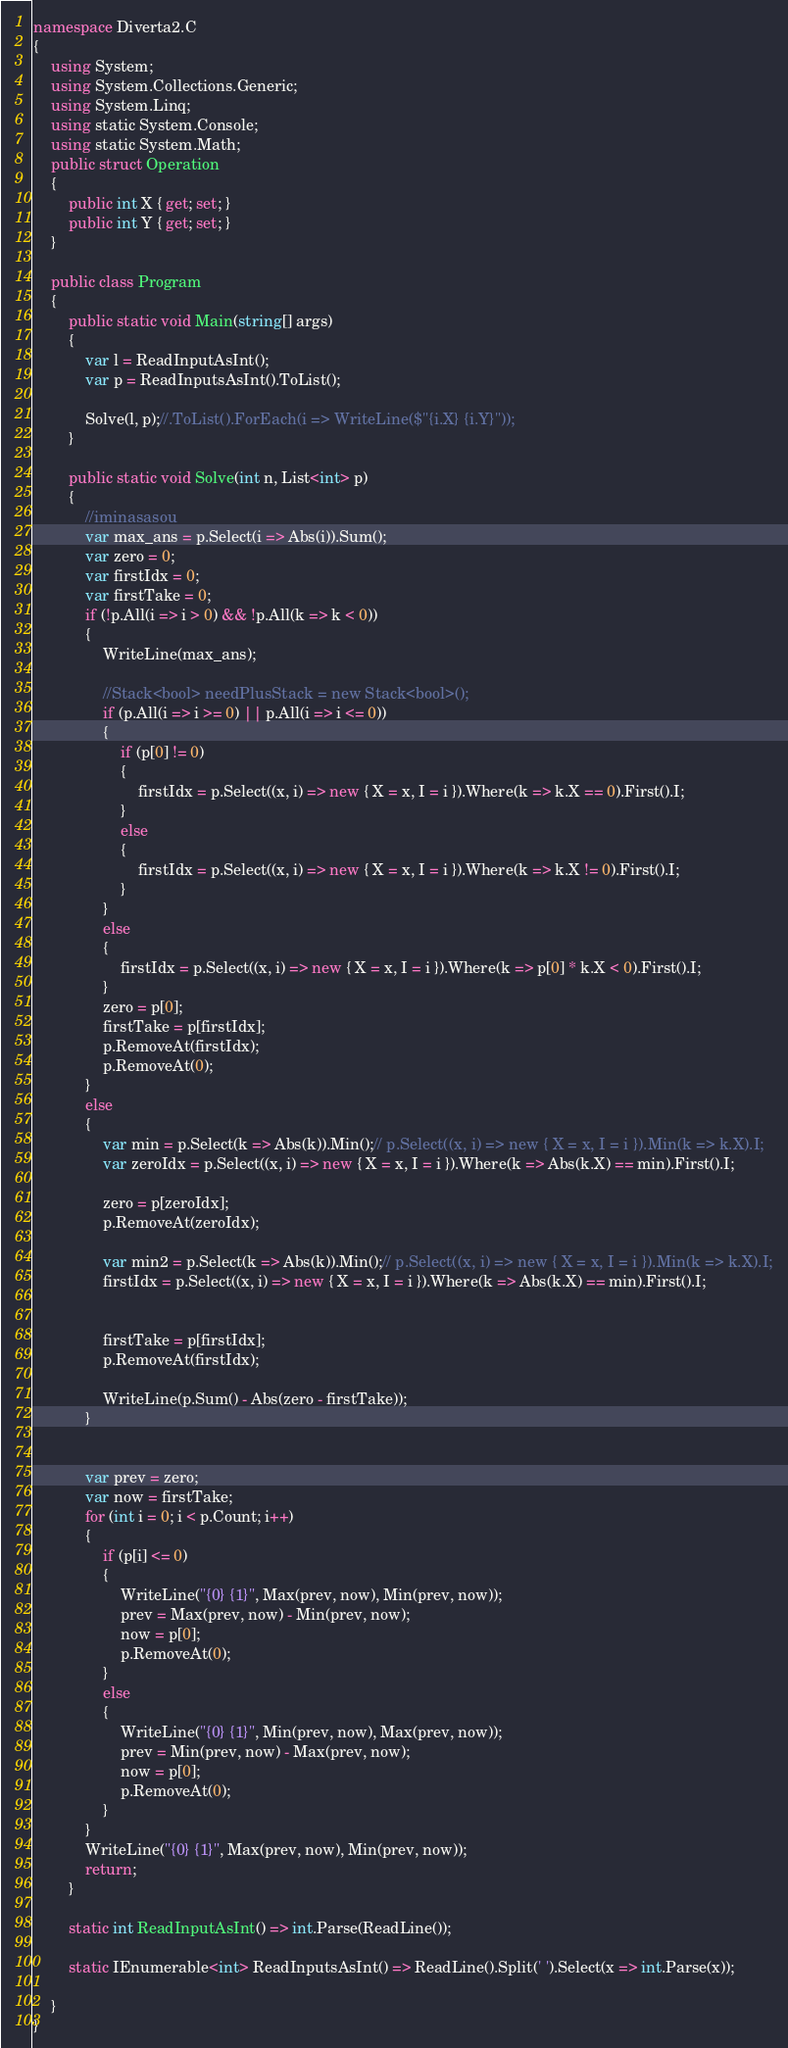<code> <loc_0><loc_0><loc_500><loc_500><_C#_>namespace Diverta2.C
{
    using System;
    using System.Collections.Generic;
    using System.Linq;
    using static System.Console;
    using static System.Math;
    public struct Operation
    {
        public int X { get; set; }
        public int Y { get; set; }
    }

    public class Program
    {
        public static void Main(string[] args)
        {
            var l = ReadInputAsInt();
            var p = ReadInputsAsInt().ToList();

            Solve(l, p);//.ToList().ForEach(i => WriteLine($"{i.X} {i.Y}"));
        }

        public static void Solve(int n, List<int> p)
        {
            //iminasasou
            var max_ans = p.Select(i => Abs(i)).Sum();
            var zero = 0;
            var firstIdx = 0;
            var firstTake = 0;
            if (!p.All(i => i > 0) && !p.All(k => k < 0))
            {
                WriteLine(max_ans);

                //Stack<bool> needPlusStack = new Stack<bool>();
                if (p.All(i => i >= 0) || p.All(i => i <= 0))
                {
                    if (p[0] != 0)
                    {
                        firstIdx = p.Select((x, i) => new { X = x, I = i }).Where(k => k.X == 0).First().I;
                    }
                    else
                    {
                        firstIdx = p.Select((x, i) => new { X = x, I = i }).Where(k => k.X != 0).First().I;
                    }
                }
                else
                {
                    firstIdx = p.Select((x, i) => new { X = x, I = i }).Where(k => p[0] * k.X < 0).First().I;
                }
                zero = p[0];
                firstTake = p[firstIdx];
                p.RemoveAt(firstIdx);
                p.RemoveAt(0);
            }
            else
            {
                var min = p.Select(k => Abs(k)).Min();// p.Select((x, i) => new { X = x, I = i }).Min(k => k.X).I;
                var zeroIdx = p.Select((x, i) => new { X = x, I = i }).Where(k => Abs(k.X) == min).First().I;

                zero = p[zeroIdx];
                p.RemoveAt(zeroIdx);

                var min2 = p.Select(k => Abs(k)).Min();// p.Select((x, i) => new { X = x, I = i }).Min(k => k.X).I;
                firstIdx = p.Select((x, i) => new { X = x, I = i }).Where(k => Abs(k.X) == min).First().I;


                firstTake = p[firstIdx];
                p.RemoveAt(firstIdx);

                WriteLine(p.Sum() - Abs(zero - firstTake));
            }


            var prev = zero;
            var now = firstTake;
            for (int i = 0; i < p.Count; i++)
            {
                if (p[i] <= 0)
                {
                    WriteLine("{0} {1}", Max(prev, now), Min(prev, now));
                    prev = Max(prev, now) - Min(prev, now);
                    now = p[0];
                    p.RemoveAt(0);
                }
                else
                {
                    WriteLine("{0} {1}", Min(prev, now), Max(prev, now));
                    prev = Min(prev, now) - Max(prev, now);
                    now = p[0];
                    p.RemoveAt(0);
                }
            }
            WriteLine("{0} {1}", Max(prev, now), Min(prev, now));
            return;
        }

        static int ReadInputAsInt() => int.Parse(ReadLine());

        static IEnumerable<int> ReadInputsAsInt() => ReadLine().Split(' ').Select(x => int.Parse(x));

    }
}
</code> 